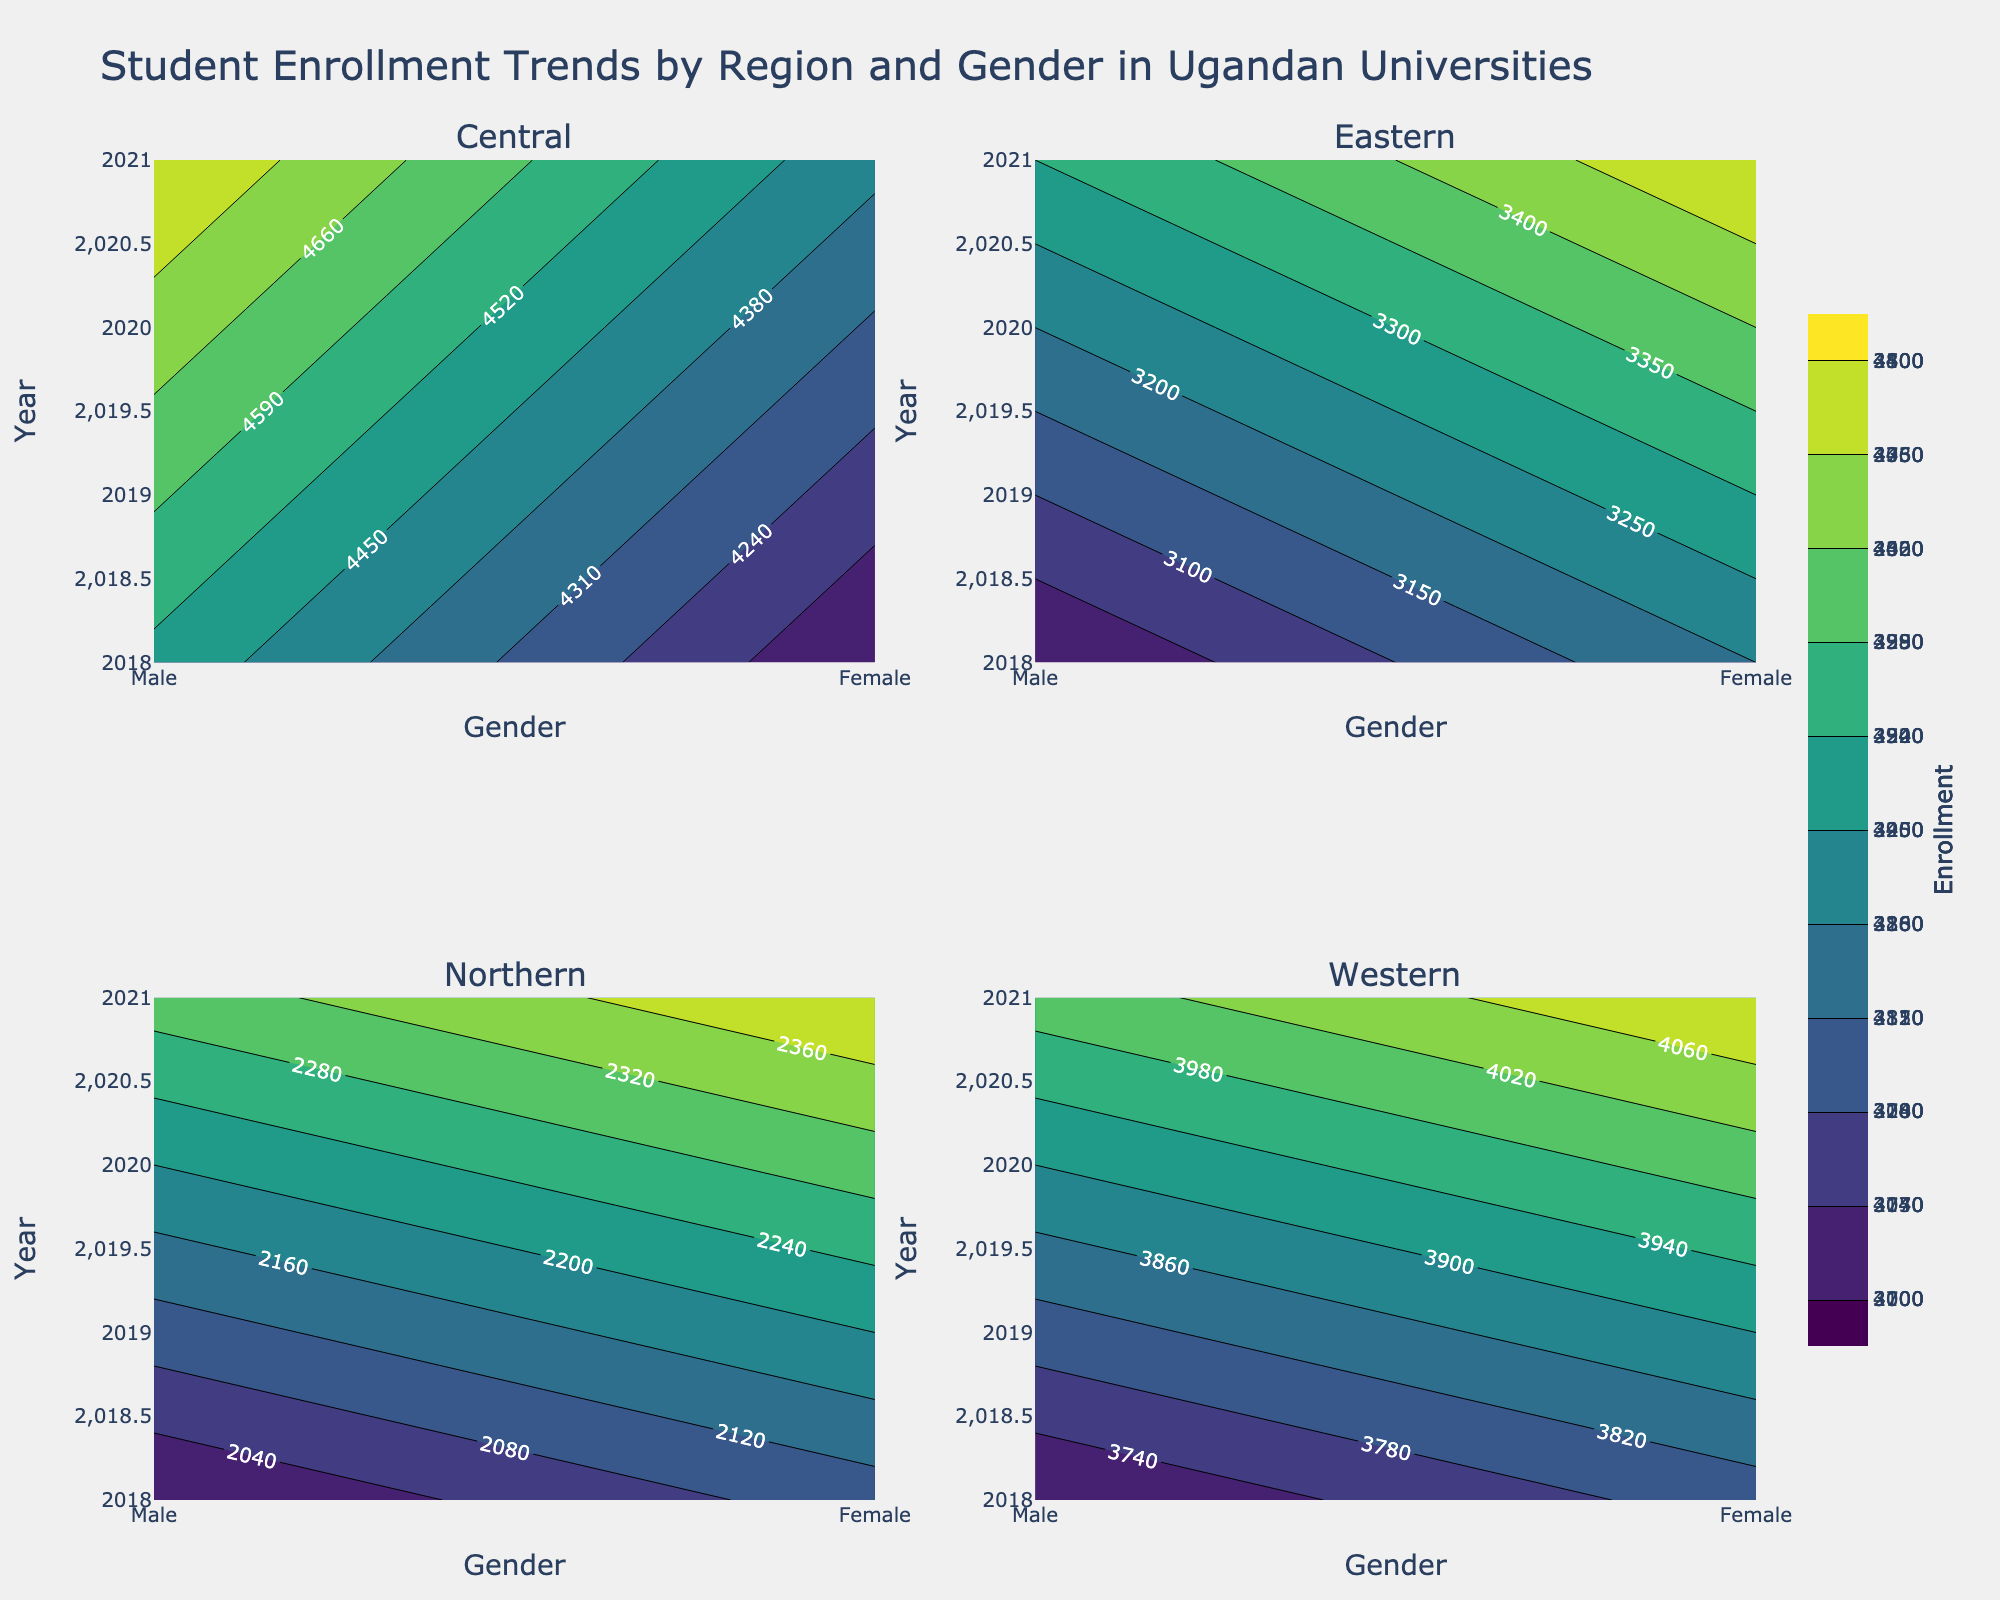How is the student enrollment trend between males and females in the Central region from 2018 to 2021? The contour plot for the Central region shows separate contours for male and female enrollments from 2018 to 2021. Comparing the contours, the trend shows a slight increase for both genders, with male enrollments rising from around 4500 to 4800 and female enrollments rising from around 4100 to 4400.
Answer: Slight increase for both genders Which region had the highest increase in student enrollment for females between 2018 and 2021? To determine the highest increase, compare the vertical distance of the contour lines for females in each sub-plot from 2018 to 2021. In the Western region, female enrollments increase from 3800 to 4100, which is the highest among the regions.
Answer: Western region Which gender had higher enrollments in the Northern region in 2020? Check the contour plot for Northern region in 2020. The contour shows that female enrollments were at 2300, whereas male enrollments were at 2200.
Answer: Female How does the total student enrollment compare between the Eastern and Western regions in 2019? In the Eastern region, 2019 enrollments are 3100 (male) + 3300 (female) = 6400. In the Western region, 2019 enrollments are 3800 (male) + 3900 (female) = 7700. Thus, the Western region has a higher total enrollment.
Answer: Western region What's the average enrollment for the Central region across the years and genders? The Central region has enrollments of [4500, 4100, 4600, 4200, 4700, 4300, 4800, 4400]. Sum = 35600. The number of data points is 8. Average = 35600 / 8 = 4450.
Answer: 4450 Compare the overall trends in student enrollments between the Northern and Eastern regions from 2018 to 2021. In the Northern region, male enrollments rise from 2000 to 2300, and female enrollments rise from 2100 to 2400, showing a slight increase. In the Eastern region, male enrollments rise from 3000 to 3300, and female enrollments rise from 3200 to 3500, also showing a slight increase but at a higher rate than the Northern region.
Answer: Eastern region showed a higher increase Are there any years where the female student enrollment in any region surpasses male enrollment? Review the contour plots for any region where the contour line for females is above that for males. In the Eastern region in 2018, female enrollments (3200) surpass male enrollments (3000).
Answer: 2018 in Eastern region What is the enrollment difference between males and females in the Western region in 2021? In the Western region in 2021, male enrollments are at 4000 and female enrollments are at 4100. The difference is 4100 - 4000 = 100.
Answer: 100 Which year had the lowest enrollment for males in the Northern region? In the Northern region contour plot, 2018 shows the lowest enrollment for males at 2000.
Answer: 2018 